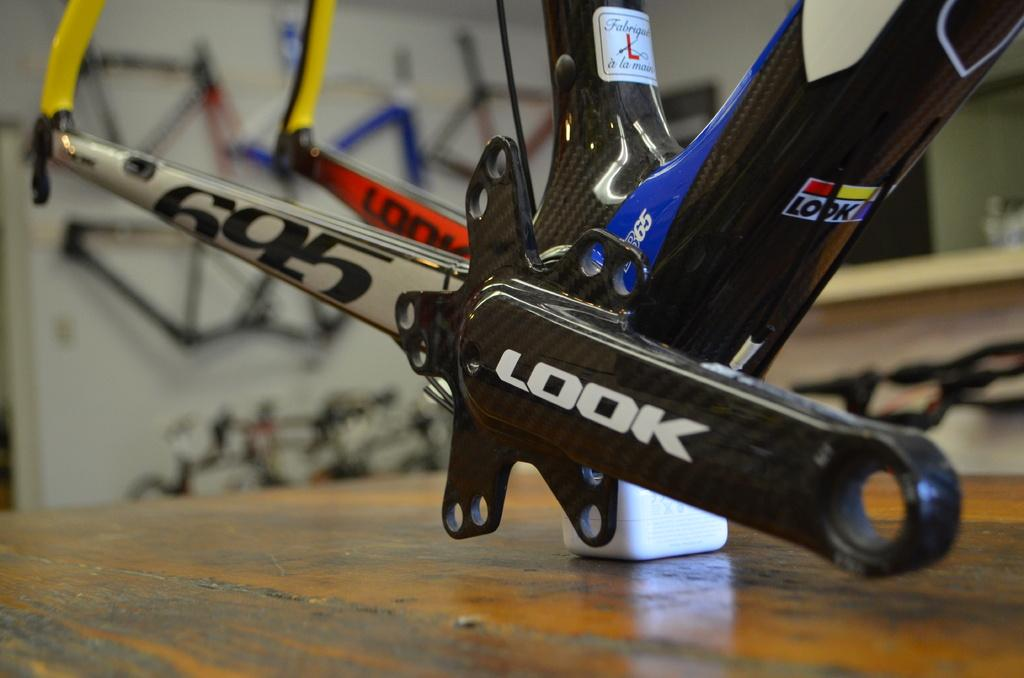What is the main object in the image? There is a bottle with a label in the image. Where is the bottle located? The bottle is placed on a surface. Can you describe another object in the image? There is another object with writing on it in the image. How would you describe the background of the image? The background of the image is blurred. What type of jelly is being sold at the store in the image? There is no store or jelly present in the image; it only features a bottle with a label and another object with writing on it. 